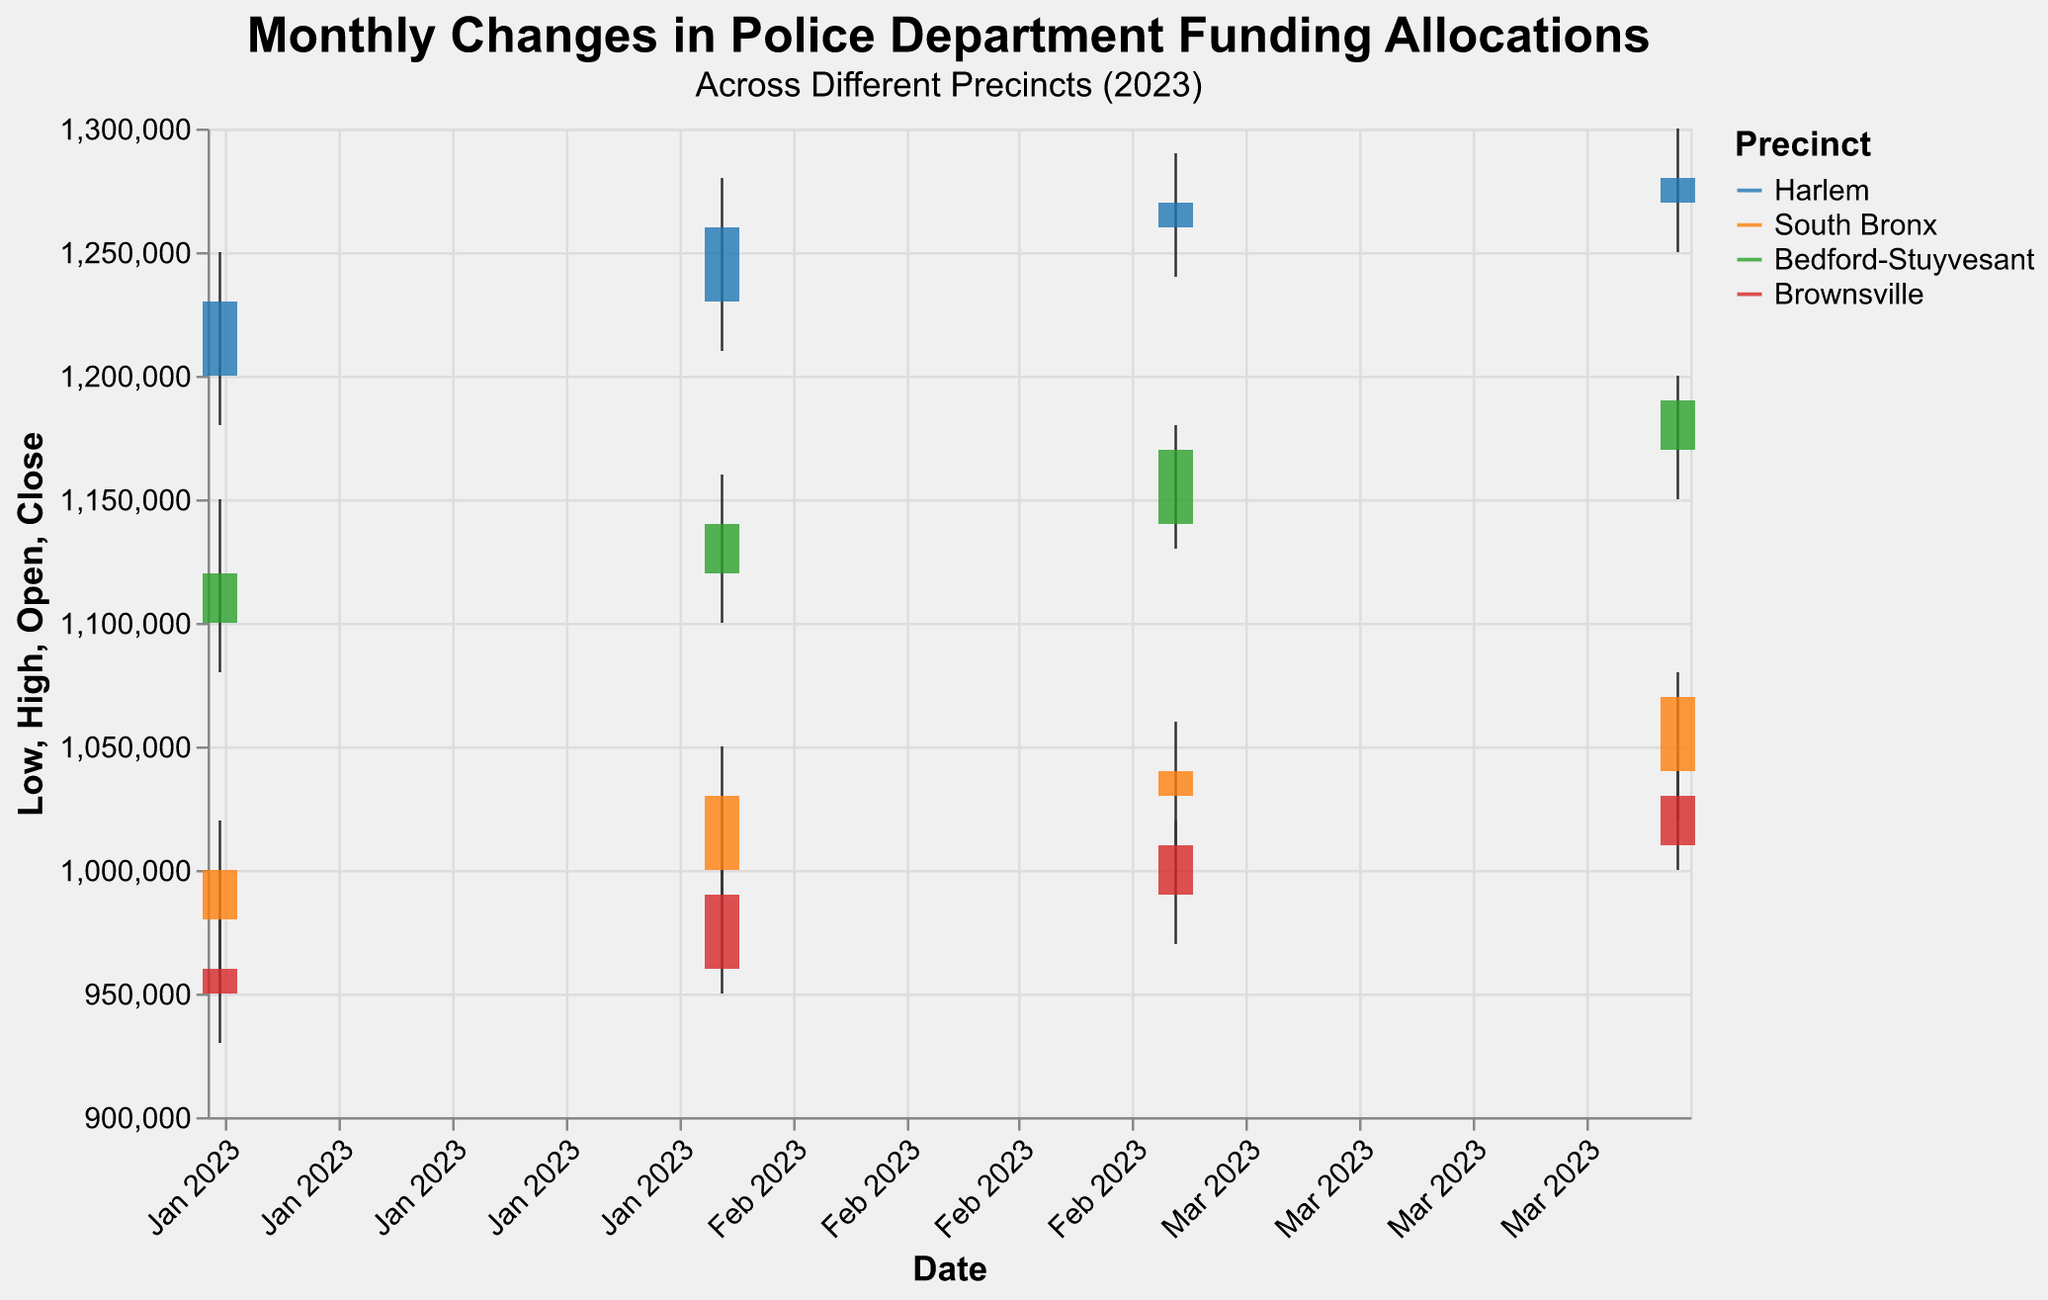Which precinct had the highest Close value in January 2023? The figure shows that Harlem had a Close value of 1,230,000. South Bronx had 1,000,000, Bedford-Stuyvesant had 1,120,000, and Brownsville had 960,000. Harlem's Close value is the highest among all precincts for January 2023.
Answer: Harlem What was the funding range (High-Low) for Bedford-Stuyvesant in March 2023? The High value is 1,180,000 and the Low value is 1,130,000. Subtracting these gives the range: 1,180,000 - 1,130,000 = 50,000.
Answer: 50,000 Which precinct showed a consistent increase in both Open and Close values from January to April 2023? By examining the Open and Close values for each month, Harlem, South Bronx, Bedford-Stuyvesant, and Brownsville each show a consistent increase from January to April 2023.
Answer: All How much did the funding allocation (Close value) increase for the South Bronx from January to April 2023? The Close value for South Bronx in January is 1,000,000 and in April it is 1,070,000. The increase is 1,070,000 - 1,000,000 = 70,000.
Answer: 70,000 Which precinct had the highest High value in April 2023, and what was it? Checking the High values for April: Harlem had 1,300,000, South Bronx had 1,080,000, Bedford-Stuyvesant had 1,200,000, and Brownsville had 1,040,000. Harlem had the highest value at 1,300,000.
Answer: Harlem, 1,300,000 Did any precinct have a Close value lower than its Open value in any month? No, all precincts show Close values that are equal to or higher than their Open values for each month.
Answer: No What is the average Open value for Brownsville over the four months? Sum the Open values: 950,000 + 960,000 + 990,000 + 1,010,000 = 3,910,000. Divide by 4: 3,910,000 / 4 = 977,500.
Answer: 977,500 Which month saw the highest Close value for Bedford-Stuyvesant, and what was this value? The Close values for Bedford-Stuyvesant: January is 1,120,000, February is 1,140,000, March is 1,170,000, and April is 1,190,000. The highest Close value is in April at 1,190,000.
Answer: April, 1,190,000 Compare the Close values of Harlem and South Bronx in February 2023. Which precinct had a higher Close value and by how much? Harlem had a Close value of 1,260,000 and South Bronx had 1,030,000 in February 2023. The difference is 1,260,000 - 1,030,000 = 230,000. Harlem had a higher Close value by 230,000.
Answer: Harlem, 230,000 